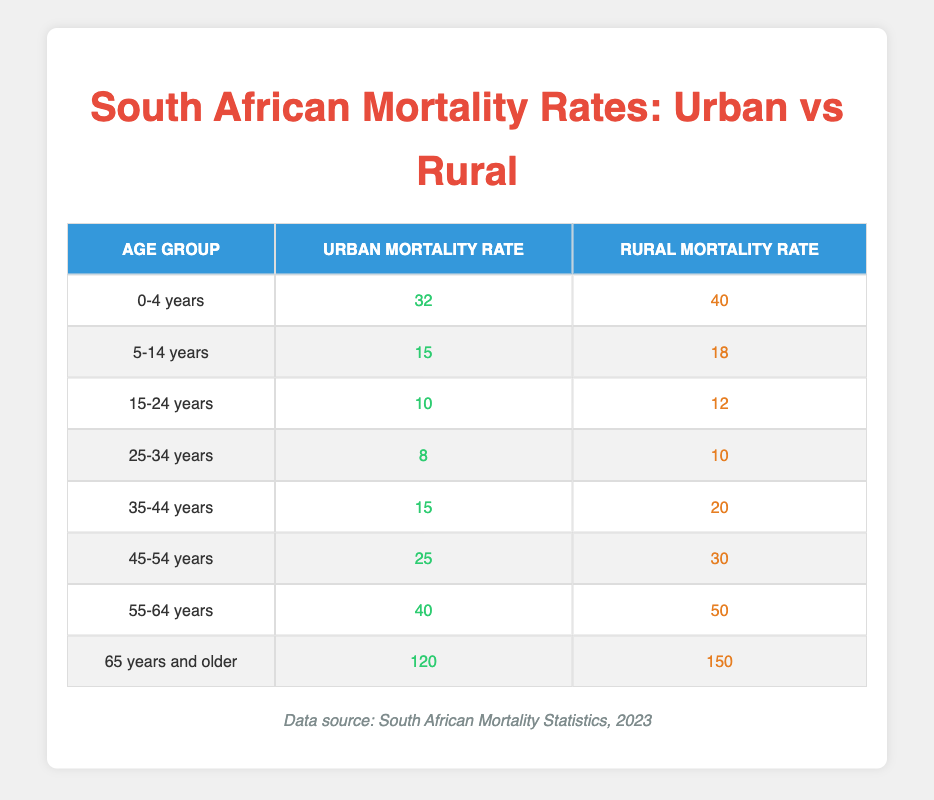What is the urban mortality rate for the age group 0-4 years? The table shows the specific mortality rates for each age group in urban areas. For the age group 0-4 years, the urban mortality rate is clearly listed as 32.
Answer: 32 What is the rural mortality rate for people aged 55-64 years? Referring directly to the table, the rural mortality rate for the age group 55-64 years is provided as 50.
Answer: 50 Which age group has the highest rural mortality rate? By examining the rural mortality rates listed in the table, I can see that the age group 65 years and older has the highest rural mortality rate at 150.
Answer: 65 years and older Is the urban mortality rate for the 45-54 years age group lower than that for the 35-44 years age group? The urban mortality rate for the 45-54 years age group is 25, and for the 35-44 years age group, it is 15. Since 25 is greater than 15, the statement is false.
Answer: No What is the difference in mortality rates between the urban and rural areas for the age group 25-34 years? The urban mortality rate for this age group is 8 and the rural mortality rate is 10. The difference can be calculated as 10 (rural) - 8 (urban) = 2.
Answer: 2 What is the average urban mortality rate across all age groups? To find the average, I will sum all the urban mortality rates: 32 + 15 + 10 + 8 + 15 + 25 + 40 + 120 = 345. There are 8 age groups, so the average is 345/8 = 43.125.
Answer: 43.125 Is the urban mortality rate for the age group 15-24 years greater than the rural mortality rate for the same age group? The table indicates that the urban mortality rate for 15-24 years is 10, while the rural mortality rate is 12. Since 10 is less than 12, the statement is false.
Answer: No What is the combined rural mortality rate for the age groups 0-4 years and 5-14 years? The rural mortality rates for these groups are 40 and 18 respectively. Adding these together gives 40 + 18 = 58.
Answer: 58 Which age group experiences the largest increase in mortality rates when comparing urban to rural areas? By comparing urban to rural mortality rates for each age group, I see: 
- 0-4 years: 40 - 32 = 8
- 5-14 years: 18 - 15 = 3
- 15-24 years: 12 - 10 = 2
- 25-34 years: 10 - 8 = 2
- 35-44 years: 20 - 15 = 5
- 45-54 years: 30 - 25 = 5
- 55-64 years: 50 - 40 = 10
- 65 years and older: 150 - 120 = 30
The largest increase is in the age group 65 years and older, with a difference of 30.
Answer: 65 years and older 